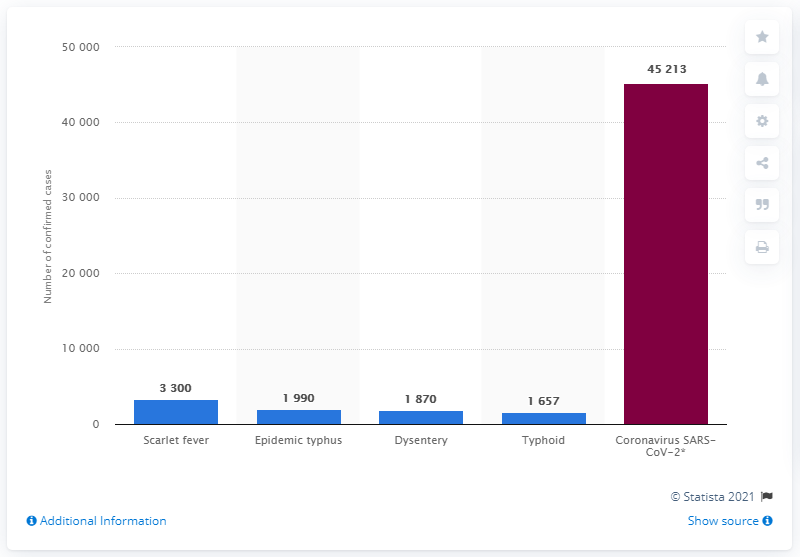Give some essential details in this illustration. In 1920, scarlet fever was the disease that contributed to the most cases. In 1920, there were a total of 8,817 cases. In Warsaw, a total of 45,213 patients have been registered with COVID-19 as of today. 